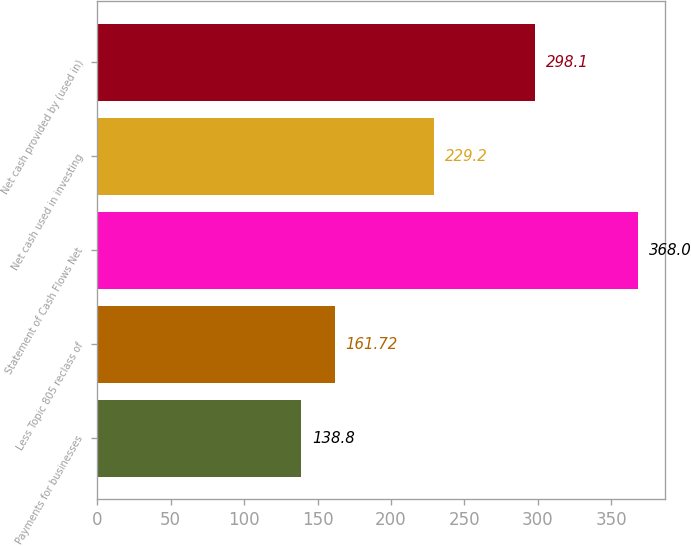Convert chart. <chart><loc_0><loc_0><loc_500><loc_500><bar_chart><fcel>Payments for businesses<fcel>Less Topic 805 reclass of<fcel>Statement of Cash Flows Net<fcel>Net cash used in investing<fcel>Net cash provided by (used in)<nl><fcel>138.8<fcel>161.72<fcel>368<fcel>229.2<fcel>298.1<nl></chart> 